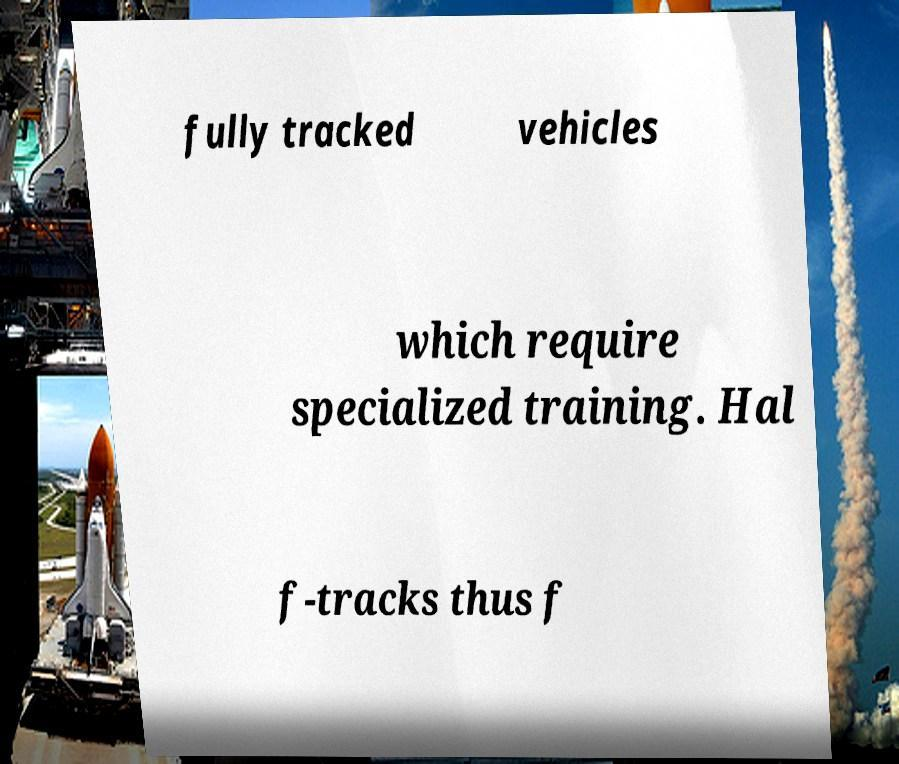Could you extract and type out the text from this image? fully tracked vehicles which require specialized training. Hal f-tracks thus f 